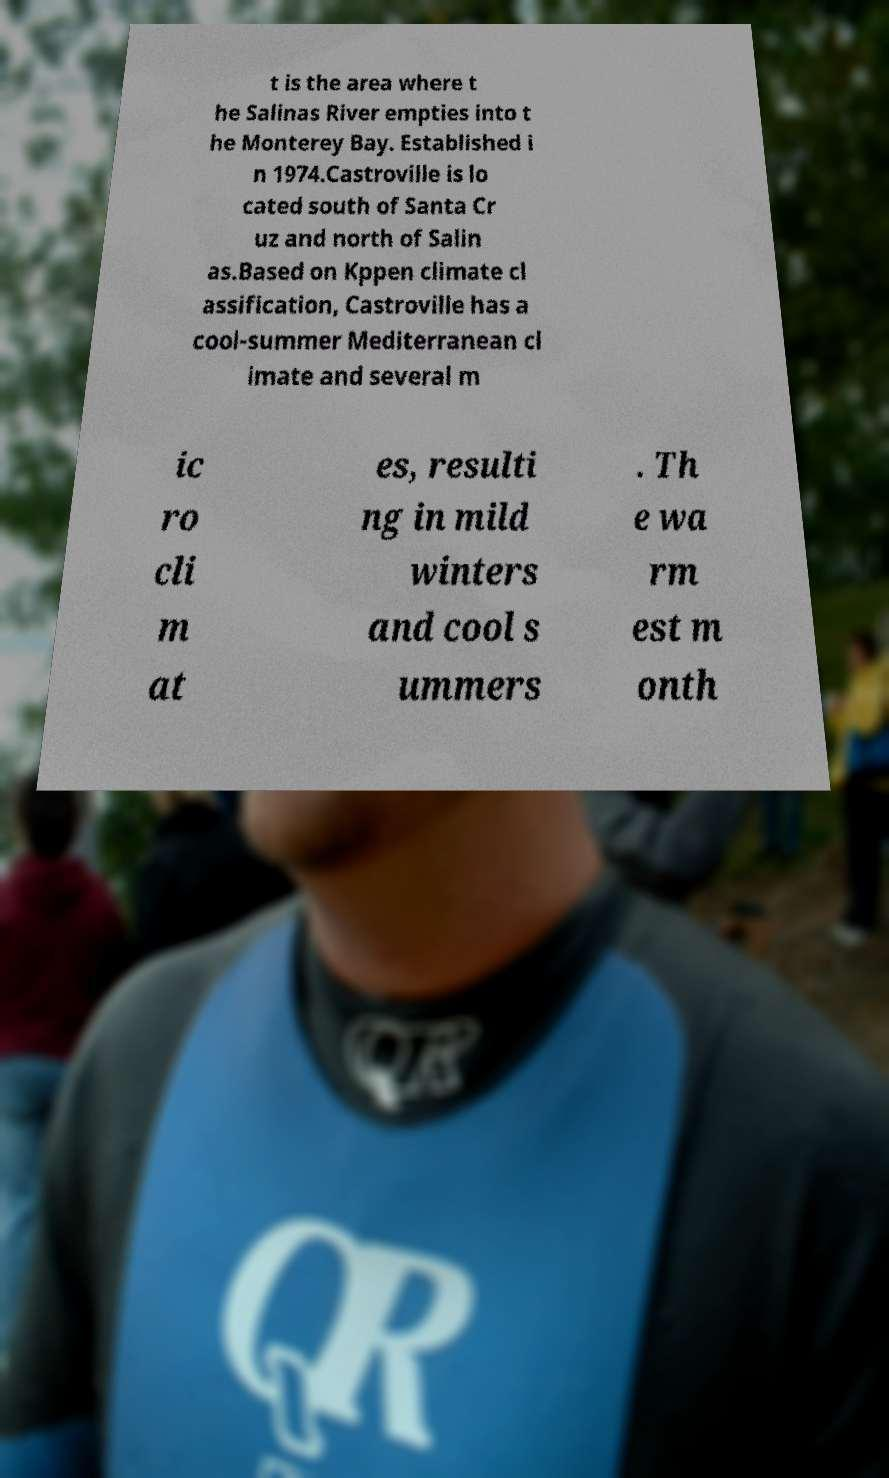What messages or text are displayed in this image? I need them in a readable, typed format. t is the area where t he Salinas River empties into t he Monterey Bay. Established i n 1974.Castroville is lo cated south of Santa Cr uz and north of Salin as.Based on Kppen climate cl assification, Castroville has a cool-summer Mediterranean cl imate and several m ic ro cli m at es, resulti ng in mild winters and cool s ummers . Th e wa rm est m onth 